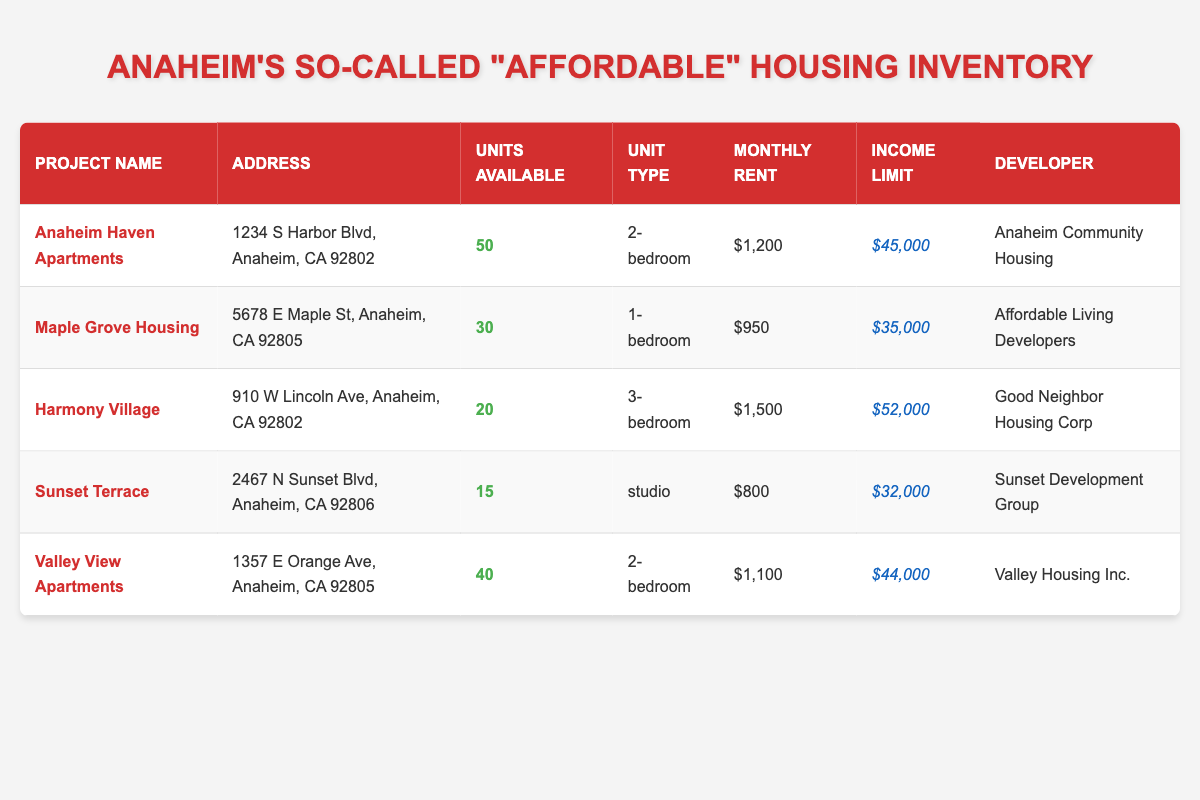What is the address of the Anaheim Haven Apartments? The address is listed in the table under the "Address" column for the project "Anaheim Haven Apartments." It specifically states "1234 S Harbor Blvd, Anaheim, CA 92802."
Answer: 1234 S Harbor Blvd, Anaheim, CA 92802 How many units are available in Maple Grove Housing? The number of available units can be found in the "Units Available" column for the project "Maple Grove Housing." It shows that there are 30 units available.
Answer: 30 What is the average monthly rent of all the projects listed? To find the average monthly rent, add up the monthly rent values: 1200 + 950 + 1500 + 800 + 1100 = 4550. Then divide by the number of projects, which is 5: 4550 / 5 = 910.
Answer: 910 Is the income limit for Harmony Village higher than that of Sunset Terrace? The income limit for Harmony Village is $52,000 and for Sunset Terrace, it is $32,000. Since $52,000 is greater than $32,000, the statement is true.
Answer: Yes What is the total number of units available across all listed projects? To get the total units available, add the units available in each project: 50 + 30 + 20 + 15 + 40 = 155.
Answer: 155 Does Valley View Apartments have a lower monthly rent than Anaheim Haven Apartments? The monthly rent for Valley View Apartments is $1,100 and for Anaheim Haven Apartments, it is $1,200. Since $1,100 is less than $1,200, the statement is true.
Answer: Yes How many projects have a monthly rent of $1,200 or less? The projects with monthly rent of $1,200 or less are "Maple Grove Housing" ($950), "Sunset Terrace" ($800), and "Valley View Apartments" ($1,100). This totals to 3 projects.
Answer: 3 Which project has the highest income limit, and what is that limit? Examining the "Income Limit" column, Harmony Village has the highest limit at $52,000.
Answer: Harmony Village, $52,000 Are there more 2-bedroom units available than 1-bedroom units? The available units for 2-bedroom apartments are from "Anaheim Haven Apartments" (50) and "Valley View Apartments" (40), totaling 90. For 1-bedroom, only "Maple Grove Housing" has 30 units. Since 90 is greater than 30, the statement is true.
Answer: Yes 